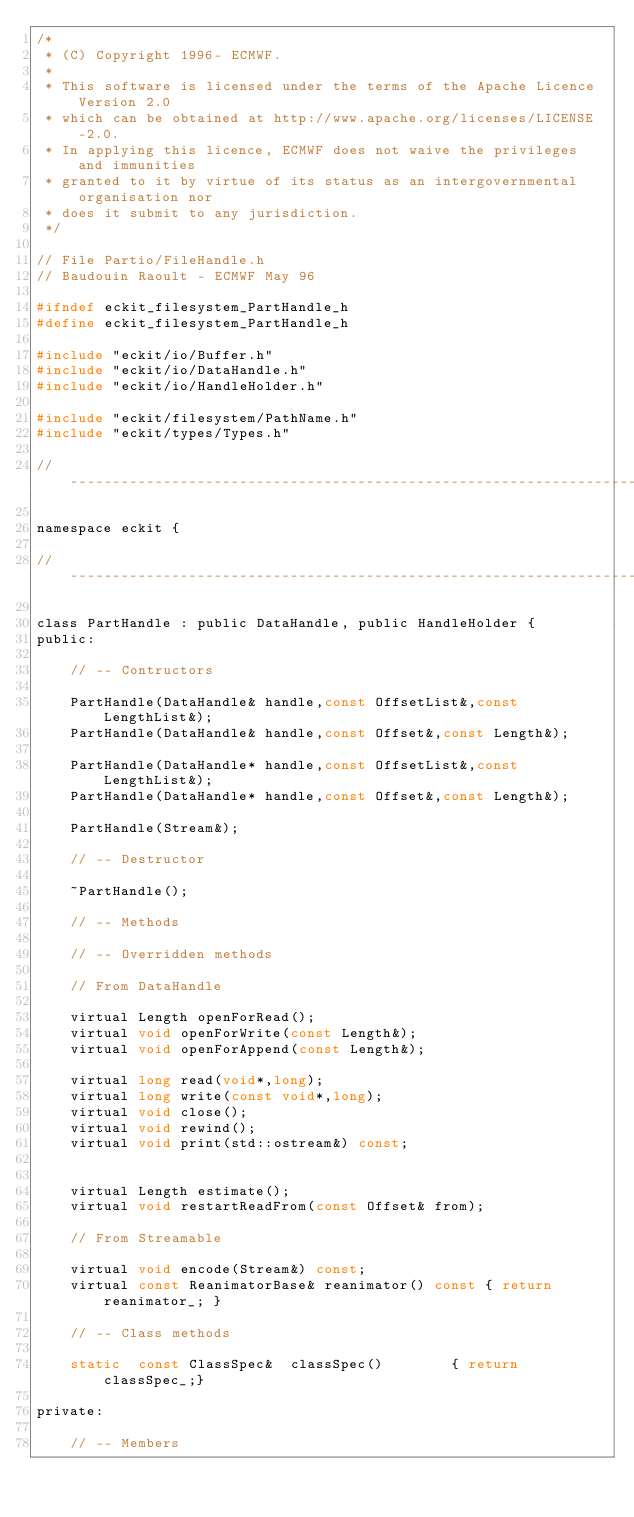Convert code to text. <code><loc_0><loc_0><loc_500><loc_500><_C_>/*
 * (C) Copyright 1996- ECMWF.
 *
 * This software is licensed under the terms of the Apache Licence Version 2.0
 * which can be obtained at http://www.apache.org/licenses/LICENSE-2.0.
 * In applying this licence, ECMWF does not waive the privileges and immunities
 * granted to it by virtue of its status as an intergovernmental organisation nor
 * does it submit to any jurisdiction.
 */

// File Partio/FileHandle.h
// Baudouin Raoult - ECMWF May 96

#ifndef eckit_filesystem_PartHandle_h
#define eckit_filesystem_PartHandle_h

#include "eckit/io/Buffer.h"
#include "eckit/io/DataHandle.h"
#include "eckit/io/HandleHolder.h"

#include "eckit/filesystem/PathName.h"
#include "eckit/types/Types.h"

//-----------------------------------------------------------------------------

namespace eckit {

//-----------------------------------------------------------------------------

class PartHandle : public DataHandle, public HandleHolder {
public:

    // -- Contructors

    PartHandle(DataHandle& handle,const OffsetList&,const LengthList&);
    PartHandle(DataHandle& handle,const Offset&,const Length&);

    PartHandle(DataHandle* handle,const OffsetList&,const LengthList&);
    PartHandle(DataHandle* handle,const Offset&,const Length&);

    PartHandle(Stream&);

    // -- Destructor

    ~PartHandle();

    // -- Methods

    // -- Overridden methods

    // From DataHandle

    virtual Length openForRead();
    virtual void openForWrite(const Length&);
    virtual void openForAppend(const Length&);

    virtual long read(void*,long);
    virtual long write(const void*,long);
    virtual void close();
    virtual void rewind();
    virtual void print(std::ostream&) const;


    virtual Length estimate();
    virtual void restartReadFrom(const Offset& from);

    // From Streamable

    virtual void encode(Stream&) const;
    virtual const ReanimatorBase& reanimator() const { return reanimator_; }

    // -- Class methods

    static  const ClassSpec&  classSpec()        { return classSpec_;}

private:

    // -- Members
</code> 